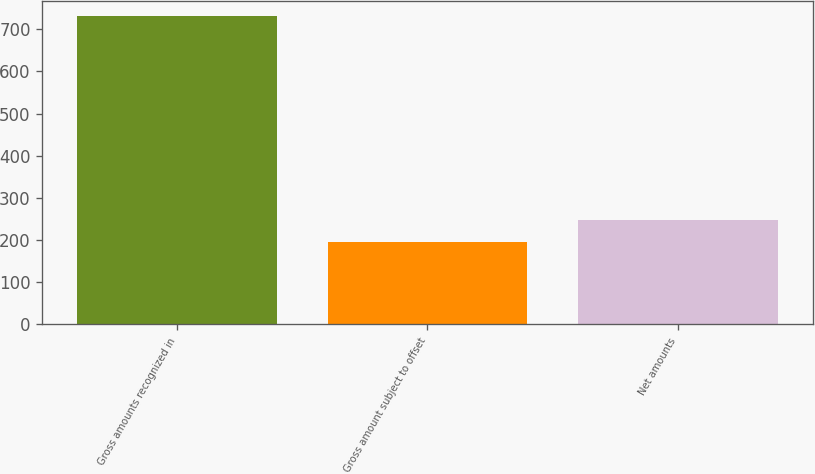Convert chart to OTSL. <chart><loc_0><loc_0><loc_500><loc_500><bar_chart><fcel>Gross amounts recognized in<fcel>Gross amount subject to offset<fcel>Net amounts<nl><fcel>731<fcel>195<fcel>248.6<nl></chart> 